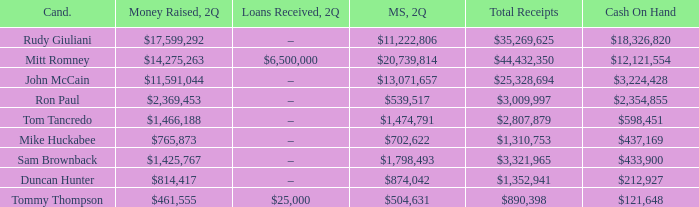Can you give me this table as a dict? {'header': ['Cand.', 'Money Raised, 2Q', 'Loans Received, 2Q', 'MS, 2Q', 'Total Receipts', 'Cash On Hand'], 'rows': [['Rudy Giuliani', '$17,599,292', '–', '$11,222,806', '$35,269,625', '$18,326,820'], ['Mitt Romney', '$14,275,263', '$6,500,000', '$20,739,814', '$44,432,350', '$12,121,554'], ['John McCain', '$11,591,044', '–', '$13,071,657', '$25,328,694', '$3,224,428'], ['Ron Paul', '$2,369,453', '–', '$539,517', '$3,009,997', '$2,354,855'], ['Tom Tancredo', '$1,466,188', '–', '$1,474,791', '$2,807,879', '$598,451'], ['Mike Huckabee', '$765,873', '–', '$702,622', '$1,310,753', '$437,169'], ['Sam Brownback', '$1,425,767', '–', '$1,798,493', '$3,321,965', '$433,900'], ['Duncan Hunter', '$814,417', '–', '$874,042', '$1,352,941', '$212,927'], ['Tommy Thompson', '$461,555', '$25,000', '$504,631', '$890,398', '$121,648']]} Tell me the total receipts for tom tancredo $2,807,879. 